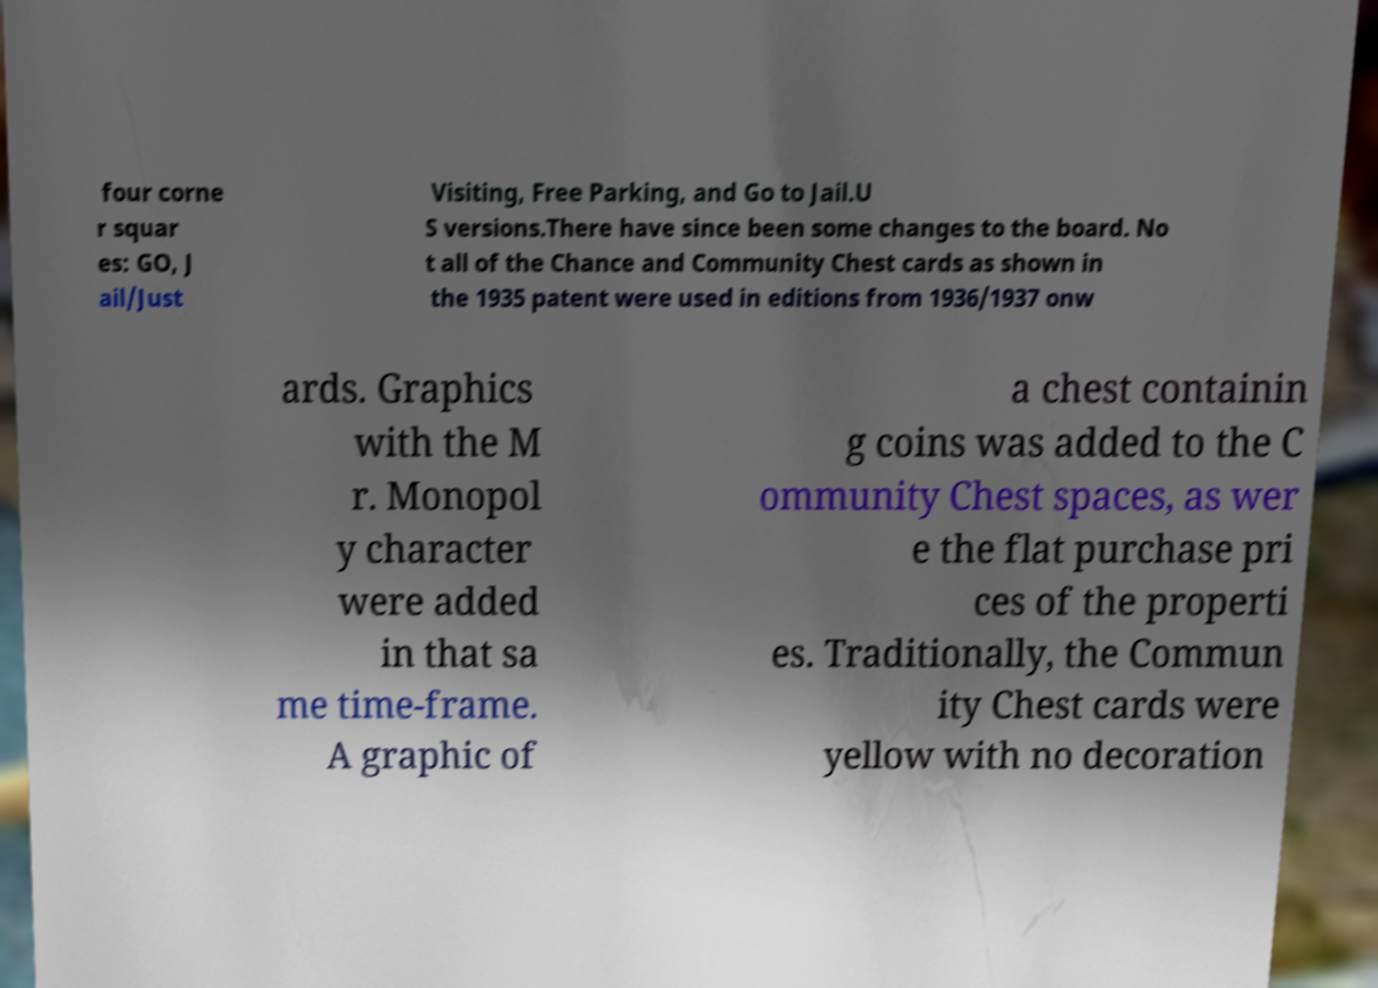What messages or text are displayed in this image? I need them in a readable, typed format. four corne r squar es: GO, J ail/Just Visiting, Free Parking, and Go to Jail.U S versions.There have since been some changes to the board. No t all of the Chance and Community Chest cards as shown in the 1935 patent were used in editions from 1936/1937 onw ards. Graphics with the M r. Monopol y character were added in that sa me time-frame. A graphic of a chest containin g coins was added to the C ommunity Chest spaces, as wer e the flat purchase pri ces of the properti es. Traditionally, the Commun ity Chest cards were yellow with no decoration 